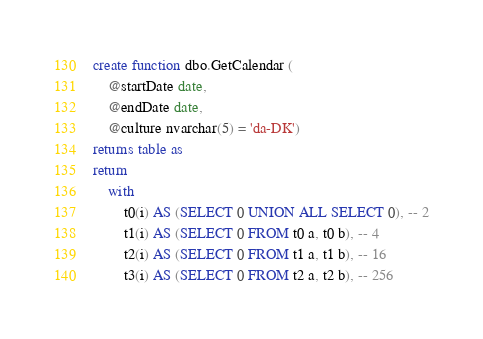<code> <loc_0><loc_0><loc_500><loc_500><_SQL_>create function dbo.GetCalendar (
    @startDate date, 
    @endDate date,
    @culture nvarchar(5) = 'da-DK')
returns table as
return
    with
        t0(i) AS (SELECT 0 UNION ALL SELECT 0), -- 2
        t1(i) AS (SELECT 0 FROM t0 a, t0 b), -- 4
        t2(i) AS (SELECT 0 FROM t1 a, t1 b), -- 16
        t3(i) AS (SELECT 0 FROM t2 a, t2 b), -- 256</code> 